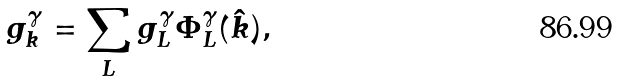Convert formula to latex. <formula><loc_0><loc_0><loc_500><loc_500>g _ { k } ^ { \gamma } = \sum _ { L } g _ { L } ^ { \gamma } \Phi _ { L } ^ { \gamma } ( { \hat { k } } ) ,</formula> 